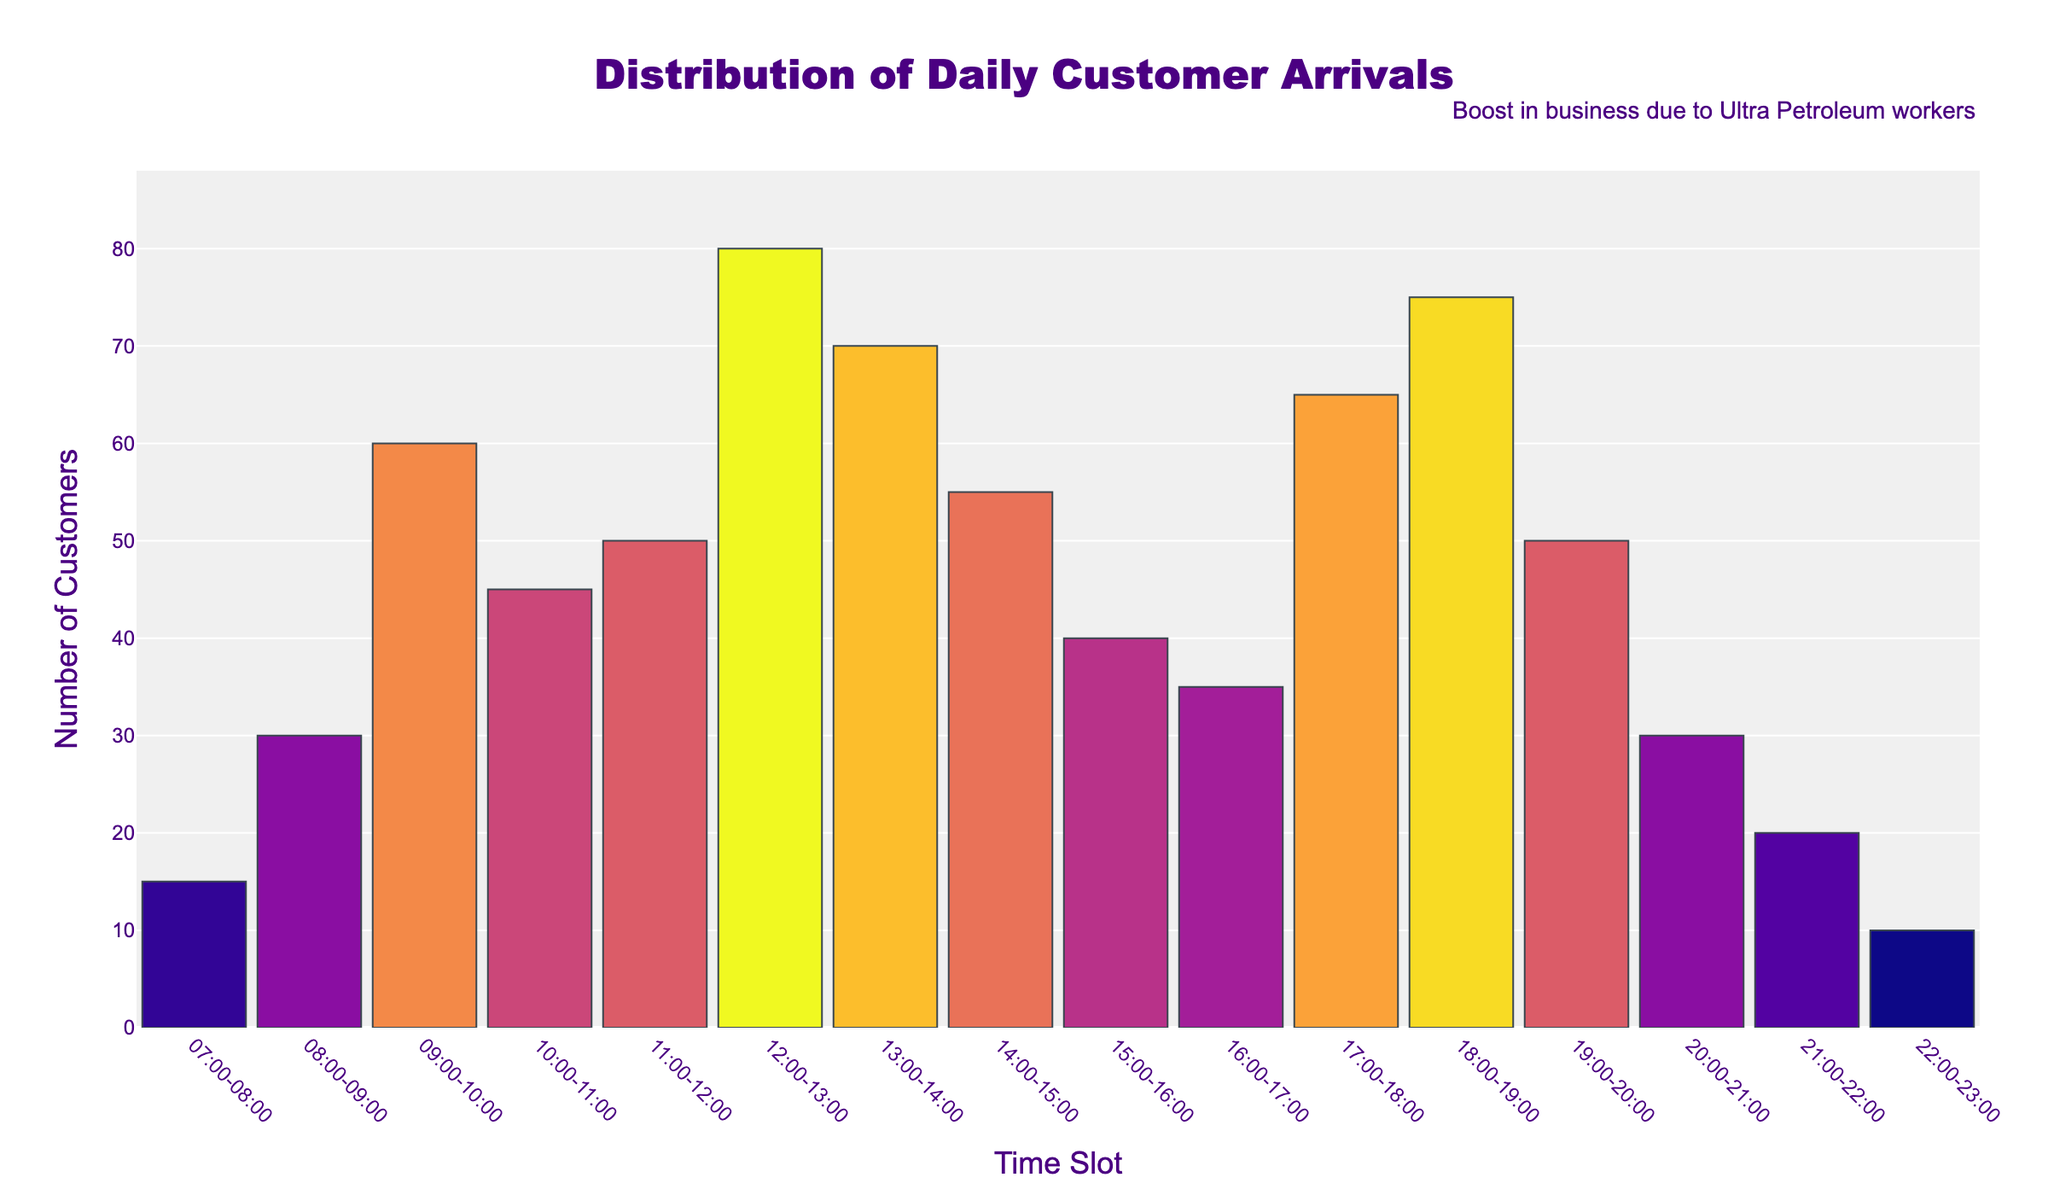What is the title of the plot? The title is displayed prominently at the top center of the plot. In this case, it reads "Distribution of Daily Customer Arrivals."
Answer: Distribution of Daily Customer Arrivals How many time slots are represented in the plot? The x-axis of the plot displays the time slots. There are 16 different time slots listed.
Answer: 16 What is the time slot with the highest number of customer arrivals? By comparing the bar heights, the highest bar corresponds to the time slot 12:00-13:00, which has 80 customer arrivals.
Answer: 12:00-13:00 Which time slot has the lowest number of customer arrivals? The shortest bar represents the time slot 22:00-23:00, which has 10 customer arrivals.
Answer: 22:00-23:00 How many customer arrivals are there between 17:00 and 19:00? Summing the customer arrivals for the time slots 17:00-18:00 (65) and 18:00-19:00 (75), we get 65 + 75 = 140.
Answer: 140 Which time slot sees more customer arrivals: 09:00-10:00 or 19:00-20:00? Comparing the bar heights of the two time slots, 09:00-10:00 has 60 customer arrivals while 19:00-20:00 has 50. Hence, 09:00-10:00 has more customer arrivals.
Answer: 09:00-10:00 How does the number of arrivals from 15:00-16:00 compare to 08:00-09:00? The bar for 15:00-16:00 shows 40 arrivals, which is higher than the 30 arrivals in the 08:00-09:00 time slot.
Answer: 15:00-16:00 has more What is the average number of customer arrivals across all time slots? Summing all the arrivals (625) and dividing by the number of time slots (16) gives us an average of 625 / 16 = 39.0625.
Answer: 39.0625 Which period has a larger increase in arrivals, 10:00-11:00 to 11:00-12:00 or 20:00-21:00 to 21:00-22:00? The increase from 10:00-11:00 (45) to 11:00-12:00 (50) is 5. The decrease from 20:00-21:00 (30) to 21:00-22:00 (20) is -10. Therefore, 10:00-11:00 to 11:00-12:00 has a larger increase.
Answer: 10:00-11:00 to 11:00-12:00 What does the annotation at the top right reference? The annotation states "Boost in business due to Ultra Petroleum workers," indicating an external factor impacting customer arrivals.
Answer: Boost in business due to Ultra Petroleum workers 